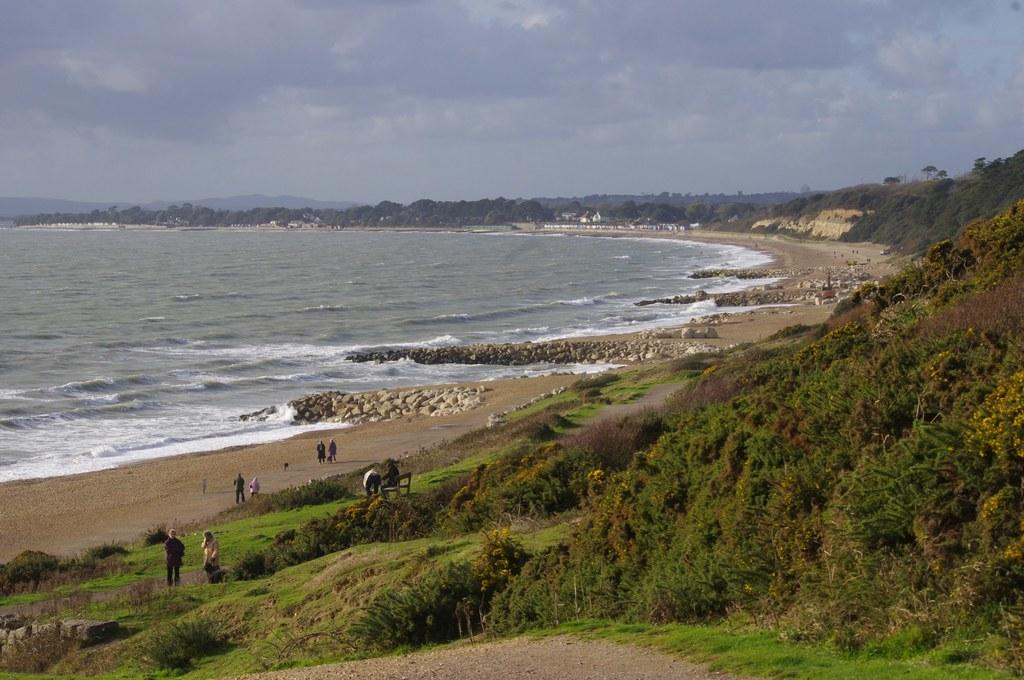What type of vegetation can be seen in the image? There are plants and trees in the image. Are there any people present in the image? Yes, there are people standing on the ground in the image. What other elements can be seen on the ground? There are stones in the image. What is located on the left side of the image? There is water on the left side of the image. What is visible in the sky in the image? The sky is visible in the image, and there are clouds in the sky. What year is depicted in the image? The image does not depict a specific year; it is a photograph of a scene with plants, trees, people, stones, water, and clouds. How many rabbits can be seen in the image? There are no rabbits present in the image. 